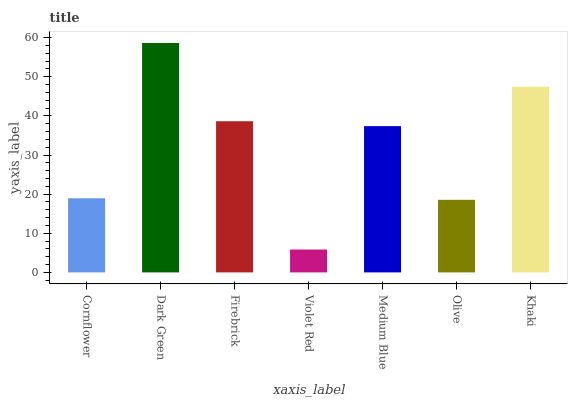Is Firebrick the minimum?
Answer yes or no. No. Is Firebrick the maximum?
Answer yes or no. No. Is Dark Green greater than Firebrick?
Answer yes or no. Yes. Is Firebrick less than Dark Green?
Answer yes or no. Yes. Is Firebrick greater than Dark Green?
Answer yes or no. No. Is Dark Green less than Firebrick?
Answer yes or no. No. Is Medium Blue the high median?
Answer yes or no. Yes. Is Medium Blue the low median?
Answer yes or no. Yes. Is Khaki the high median?
Answer yes or no. No. Is Violet Red the low median?
Answer yes or no. No. 